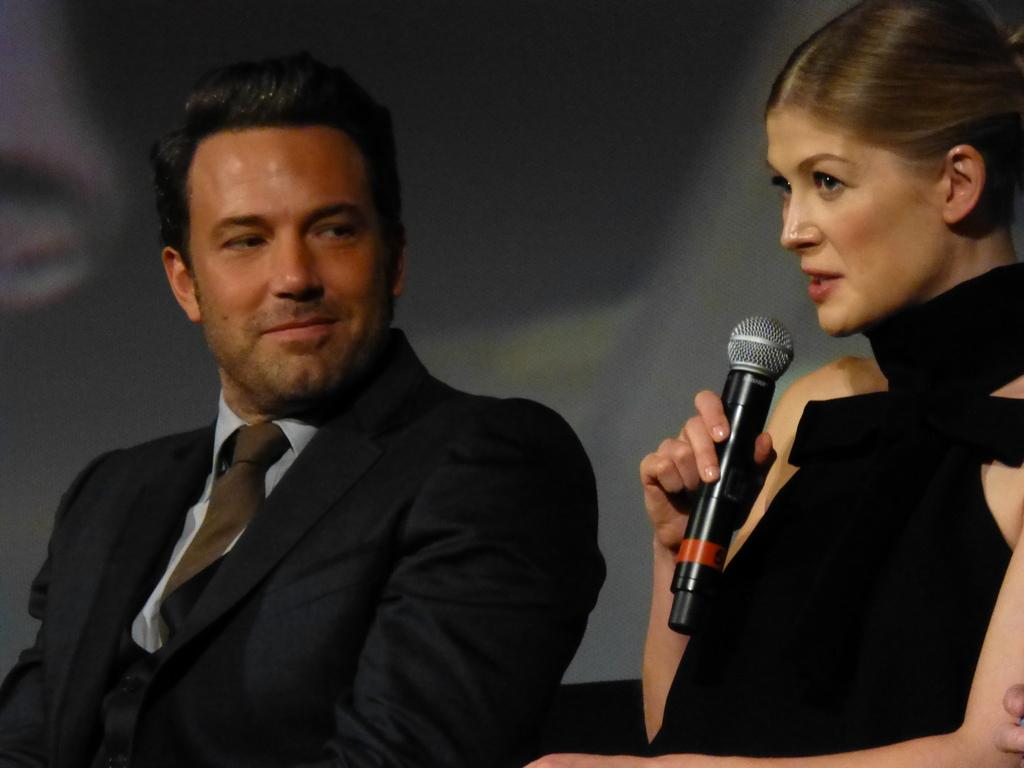How many people are present in the image? There are two people in the image, a man and a woman. What are the man and woman doing in the image? Both the man and woman are seated on chairs. Can you describe the woman with the microphone? There is a woman with a microphone in the image, and she is speaking. What type of seed is being planted in the wilderness by the woman with the microphone? There is no wilderness or seed planting depicted in the image. 